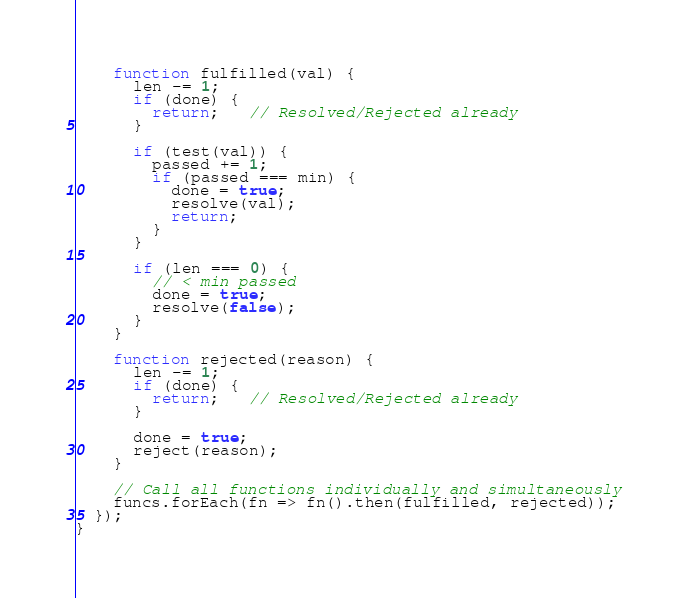<code> <loc_0><loc_0><loc_500><loc_500><_JavaScript_>    function fulfilled(val) {
      len -= 1;
      if (done) {
        return;   // Resolved/Rejected already
      }

      if (test(val)) {
        passed += 1;
        if (passed === min) {
          done = true;
          resolve(val);
          return;
        }
      }

      if (len === 0) {
        // < min passed
        done = true;
        resolve(false);
      }
    }

    function rejected(reason) {
      len -= 1;
      if (done) {
        return;   // Resolved/Rejected already
      }

      done = true;
      reject(reason);
    }

    // Call all functions individually and simultaneously
    funcs.forEach(fn => fn().then(fulfilled, rejected));
  });
}
</code> 